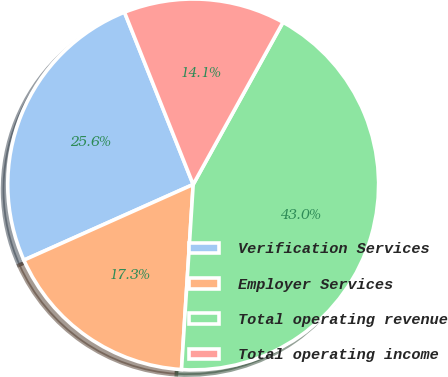Convert chart. <chart><loc_0><loc_0><loc_500><loc_500><pie_chart><fcel>Verification Services<fcel>Employer Services<fcel>Total operating revenue<fcel>Total operating income<nl><fcel>25.65%<fcel>17.31%<fcel>42.96%<fcel>14.09%<nl></chart> 